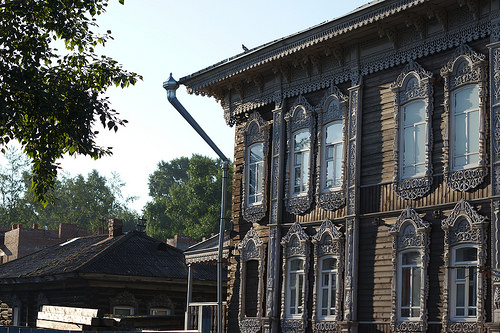<image>
Is there a bird in the sky? No. The bird is not contained within the sky. These objects have a different spatial relationship. 